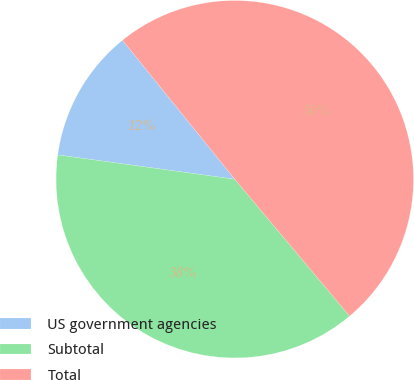Convert chart to OTSL. <chart><loc_0><loc_0><loc_500><loc_500><pie_chart><fcel>US government agencies<fcel>Subtotal<fcel>Total<nl><fcel>12.01%<fcel>38.28%<fcel>49.71%<nl></chart> 